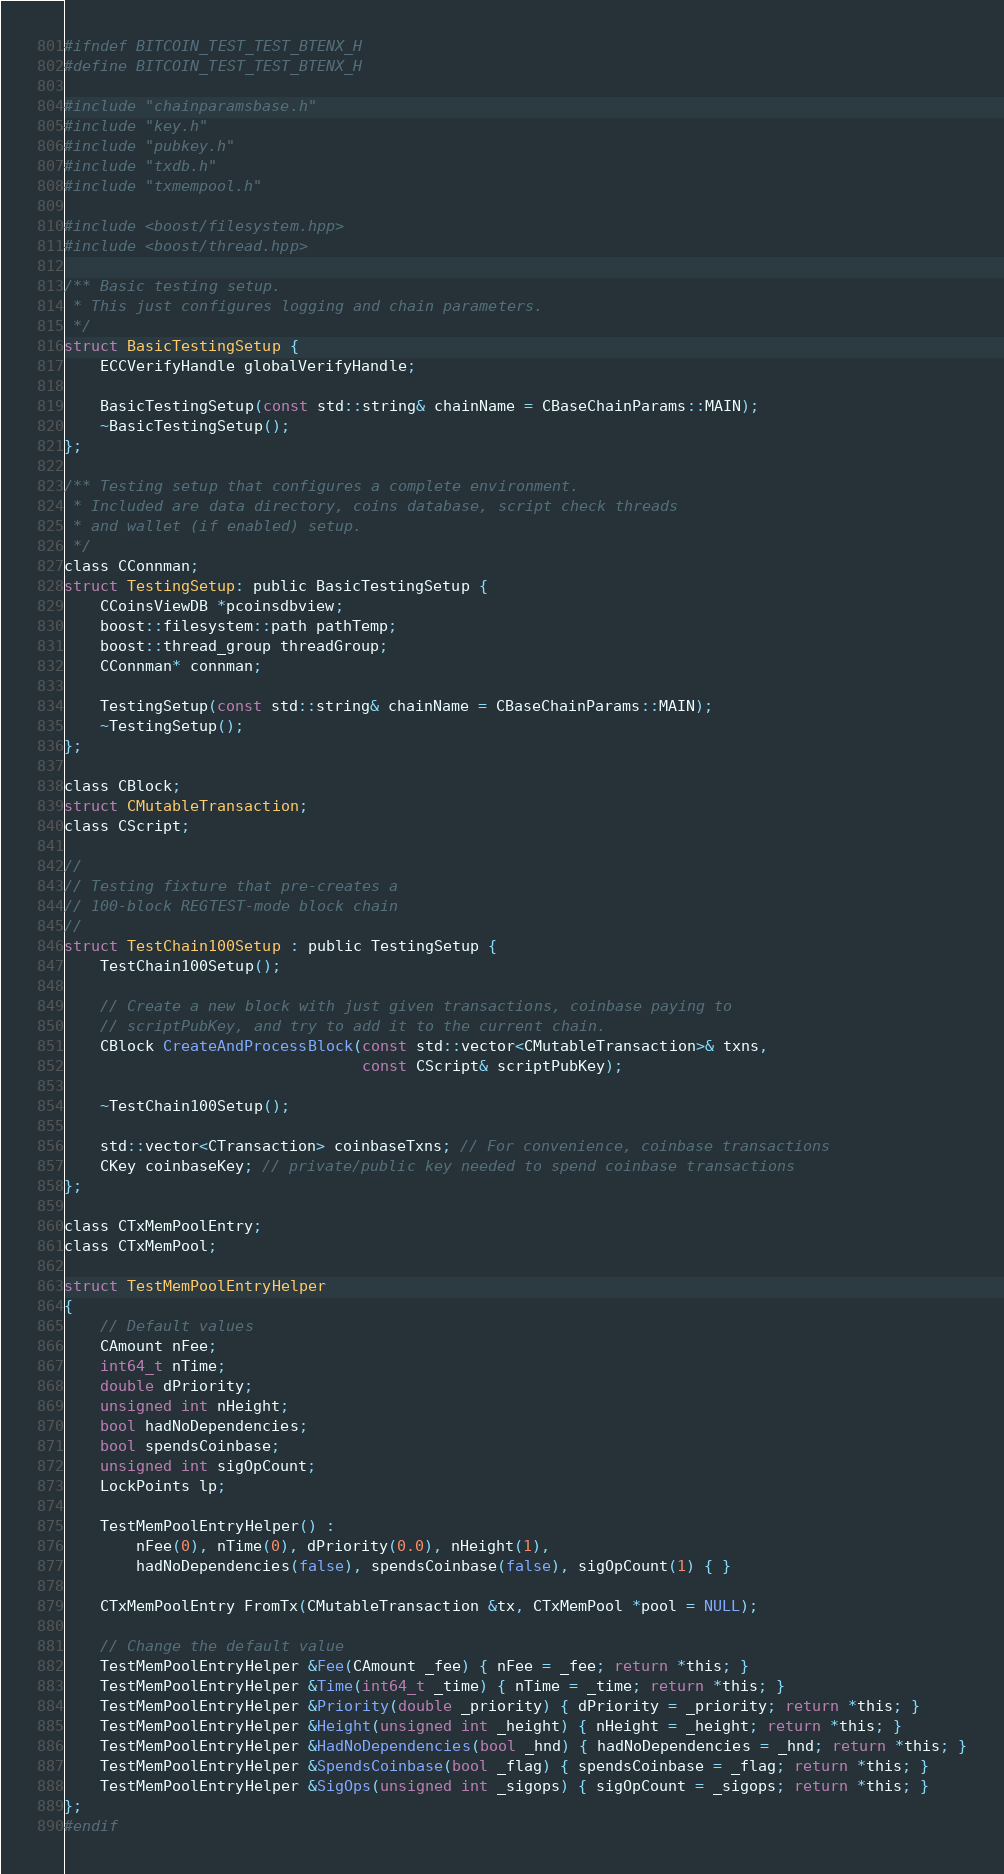Convert code to text. <code><loc_0><loc_0><loc_500><loc_500><_C_>#ifndef BITCOIN_TEST_TEST_BTENX_H
#define BITCOIN_TEST_TEST_BTENX_H

#include "chainparamsbase.h"
#include "key.h"
#include "pubkey.h"
#include "txdb.h"
#include "txmempool.h"

#include <boost/filesystem.hpp>
#include <boost/thread.hpp>

/** Basic testing setup.
 * This just configures logging and chain parameters.
 */
struct BasicTestingSetup {
    ECCVerifyHandle globalVerifyHandle;

    BasicTestingSetup(const std::string& chainName = CBaseChainParams::MAIN);
    ~BasicTestingSetup();
};

/** Testing setup that configures a complete environment.
 * Included are data directory, coins database, script check threads
 * and wallet (if enabled) setup.
 */
class CConnman;
struct TestingSetup: public BasicTestingSetup {
    CCoinsViewDB *pcoinsdbview;
    boost::filesystem::path pathTemp;
    boost::thread_group threadGroup;
    CConnman* connman;

    TestingSetup(const std::string& chainName = CBaseChainParams::MAIN);
    ~TestingSetup();
};

class CBlock;
struct CMutableTransaction;
class CScript;

//
// Testing fixture that pre-creates a
// 100-block REGTEST-mode block chain
//
struct TestChain100Setup : public TestingSetup {
    TestChain100Setup();

    // Create a new block with just given transactions, coinbase paying to
    // scriptPubKey, and try to add it to the current chain.
    CBlock CreateAndProcessBlock(const std::vector<CMutableTransaction>& txns,
                                 const CScript& scriptPubKey);

    ~TestChain100Setup();

    std::vector<CTransaction> coinbaseTxns; // For convenience, coinbase transactions
    CKey coinbaseKey; // private/public key needed to spend coinbase transactions
};

class CTxMemPoolEntry;
class CTxMemPool;

struct TestMemPoolEntryHelper
{
    // Default values
    CAmount nFee;
    int64_t nTime;
    double dPriority;
    unsigned int nHeight;
    bool hadNoDependencies;
    bool spendsCoinbase;
    unsigned int sigOpCount;
    LockPoints lp;

    TestMemPoolEntryHelper() :
        nFee(0), nTime(0), dPriority(0.0), nHeight(1),
        hadNoDependencies(false), spendsCoinbase(false), sigOpCount(1) { }
    
    CTxMemPoolEntry FromTx(CMutableTransaction &tx, CTxMemPool *pool = NULL);

    // Change the default value
    TestMemPoolEntryHelper &Fee(CAmount _fee) { nFee = _fee; return *this; }
    TestMemPoolEntryHelper &Time(int64_t _time) { nTime = _time; return *this; }
    TestMemPoolEntryHelper &Priority(double _priority) { dPriority = _priority; return *this; }
    TestMemPoolEntryHelper &Height(unsigned int _height) { nHeight = _height; return *this; }
    TestMemPoolEntryHelper &HadNoDependencies(bool _hnd) { hadNoDependencies = _hnd; return *this; }
    TestMemPoolEntryHelper &SpendsCoinbase(bool _flag) { spendsCoinbase = _flag; return *this; }
    TestMemPoolEntryHelper &SigOps(unsigned int _sigops) { sigOpCount = _sigops; return *this; }
};
#endif
</code> 